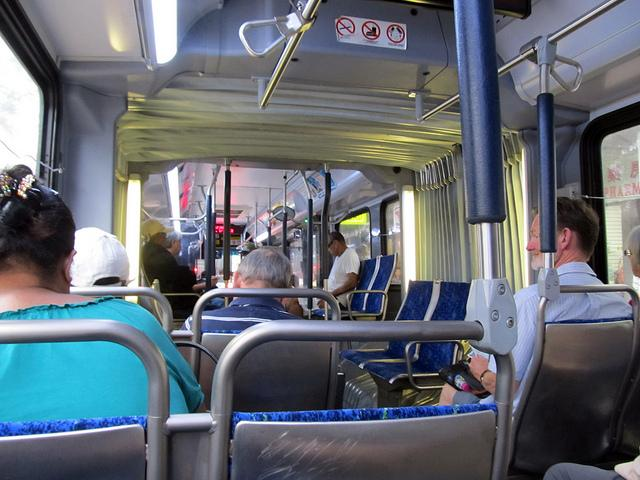What is explicitly forbidden on the bus?

Choices:
A) spitting
B) eating
C) singing
D) talking eating 